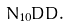<formula> <loc_0><loc_0><loc_500><loc_500>N _ { 1 0 } \bar { D } D .</formula> 